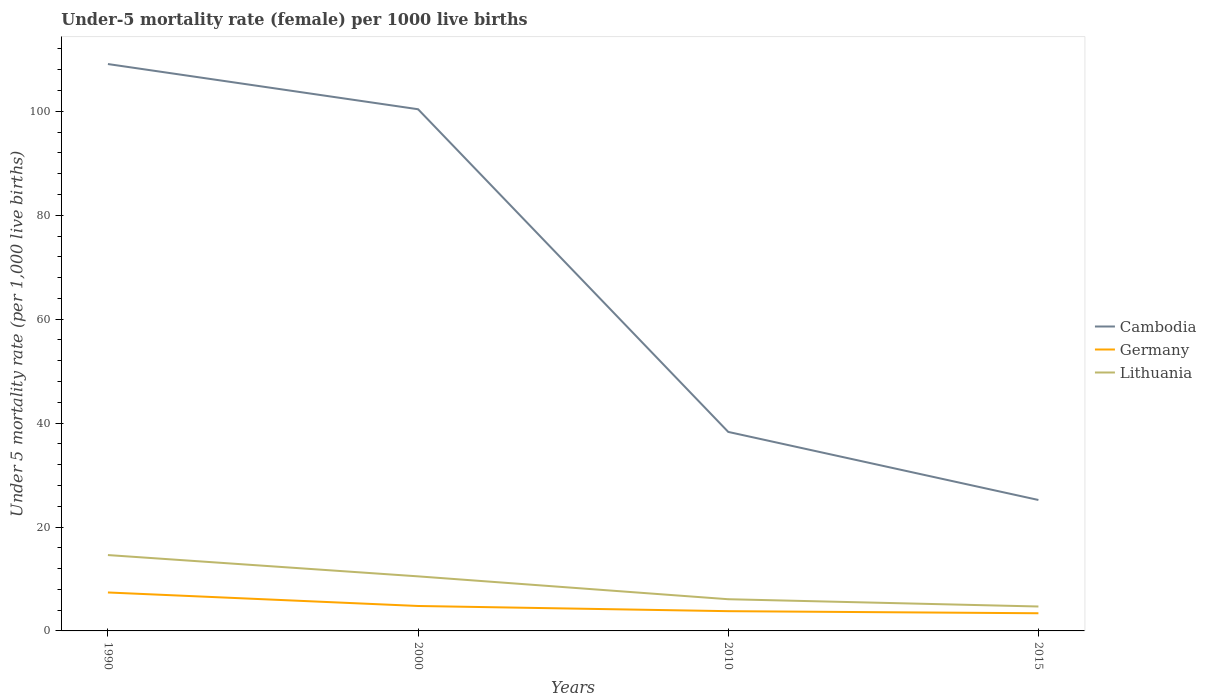Does the line corresponding to Lithuania intersect with the line corresponding to Cambodia?
Offer a very short reply. No. Across all years, what is the maximum under-five mortality rate in Cambodia?
Your response must be concise. 25.2. In which year was the under-five mortality rate in Lithuania maximum?
Provide a short and direct response. 2015. What is the difference between the highest and the second highest under-five mortality rate in Cambodia?
Give a very brief answer. 83.9. How many lines are there?
Provide a succinct answer. 3. Does the graph contain any zero values?
Ensure brevity in your answer.  No. How many legend labels are there?
Your response must be concise. 3. How are the legend labels stacked?
Your answer should be very brief. Vertical. What is the title of the graph?
Your response must be concise. Under-5 mortality rate (female) per 1000 live births. What is the label or title of the X-axis?
Your answer should be compact. Years. What is the label or title of the Y-axis?
Give a very brief answer. Under 5 mortality rate (per 1,0 live births). What is the Under 5 mortality rate (per 1,000 live births) in Cambodia in 1990?
Make the answer very short. 109.1. What is the Under 5 mortality rate (per 1,000 live births) in Lithuania in 1990?
Ensure brevity in your answer.  14.6. What is the Under 5 mortality rate (per 1,000 live births) of Cambodia in 2000?
Give a very brief answer. 100.4. What is the Under 5 mortality rate (per 1,000 live births) in Germany in 2000?
Your answer should be very brief. 4.8. What is the Under 5 mortality rate (per 1,000 live births) of Cambodia in 2010?
Provide a succinct answer. 38.3. What is the Under 5 mortality rate (per 1,000 live births) of Cambodia in 2015?
Your answer should be very brief. 25.2. What is the Under 5 mortality rate (per 1,000 live births) in Germany in 2015?
Offer a very short reply. 3.4. Across all years, what is the maximum Under 5 mortality rate (per 1,000 live births) of Cambodia?
Your answer should be very brief. 109.1. Across all years, what is the maximum Under 5 mortality rate (per 1,000 live births) in Lithuania?
Ensure brevity in your answer.  14.6. Across all years, what is the minimum Under 5 mortality rate (per 1,000 live births) of Cambodia?
Offer a terse response. 25.2. Across all years, what is the minimum Under 5 mortality rate (per 1,000 live births) in Germany?
Offer a very short reply. 3.4. Across all years, what is the minimum Under 5 mortality rate (per 1,000 live births) of Lithuania?
Offer a very short reply. 4.7. What is the total Under 5 mortality rate (per 1,000 live births) of Cambodia in the graph?
Your answer should be compact. 273. What is the total Under 5 mortality rate (per 1,000 live births) of Germany in the graph?
Ensure brevity in your answer.  19.4. What is the total Under 5 mortality rate (per 1,000 live births) in Lithuania in the graph?
Give a very brief answer. 35.9. What is the difference between the Under 5 mortality rate (per 1,000 live births) of Cambodia in 1990 and that in 2000?
Your answer should be very brief. 8.7. What is the difference between the Under 5 mortality rate (per 1,000 live births) in Lithuania in 1990 and that in 2000?
Provide a short and direct response. 4.1. What is the difference between the Under 5 mortality rate (per 1,000 live births) in Cambodia in 1990 and that in 2010?
Give a very brief answer. 70.8. What is the difference between the Under 5 mortality rate (per 1,000 live births) in Germany in 1990 and that in 2010?
Give a very brief answer. 3.6. What is the difference between the Under 5 mortality rate (per 1,000 live births) in Lithuania in 1990 and that in 2010?
Ensure brevity in your answer.  8.5. What is the difference between the Under 5 mortality rate (per 1,000 live births) in Cambodia in 1990 and that in 2015?
Provide a succinct answer. 83.9. What is the difference between the Under 5 mortality rate (per 1,000 live births) in Cambodia in 2000 and that in 2010?
Provide a short and direct response. 62.1. What is the difference between the Under 5 mortality rate (per 1,000 live births) of Lithuania in 2000 and that in 2010?
Your response must be concise. 4.4. What is the difference between the Under 5 mortality rate (per 1,000 live births) of Cambodia in 2000 and that in 2015?
Offer a terse response. 75.2. What is the difference between the Under 5 mortality rate (per 1,000 live births) in Germany in 2000 and that in 2015?
Your answer should be very brief. 1.4. What is the difference between the Under 5 mortality rate (per 1,000 live births) of Lithuania in 2000 and that in 2015?
Provide a succinct answer. 5.8. What is the difference between the Under 5 mortality rate (per 1,000 live births) in Lithuania in 2010 and that in 2015?
Keep it short and to the point. 1.4. What is the difference between the Under 5 mortality rate (per 1,000 live births) of Cambodia in 1990 and the Under 5 mortality rate (per 1,000 live births) of Germany in 2000?
Provide a succinct answer. 104.3. What is the difference between the Under 5 mortality rate (per 1,000 live births) in Cambodia in 1990 and the Under 5 mortality rate (per 1,000 live births) in Lithuania in 2000?
Your answer should be very brief. 98.6. What is the difference between the Under 5 mortality rate (per 1,000 live births) in Germany in 1990 and the Under 5 mortality rate (per 1,000 live births) in Lithuania in 2000?
Provide a succinct answer. -3.1. What is the difference between the Under 5 mortality rate (per 1,000 live births) in Cambodia in 1990 and the Under 5 mortality rate (per 1,000 live births) in Germany in 2010?
Ensure brevity in your answer.  105.3. What is the difference between the Under 5 mortality rate (per 1,000 live births) in Cambodia in 1990 and the Under 5 mortality rate (per 1,000 live births) in Lithuania in 2010?
Keep it short and to the point. 103. What is the difference between the Under 5 mortality rate (per 1,000 live births) of Cambodia in 1990 and the Under 5 mortality rate (per 1,000 live births) of Germany in 2015?
Your answer should be very brief. 105.7. What is the difference between the Under 5 mortality rate (per 1,000 live births) in Cambodia in 1990 and the Under 5 mortality rate (per 1,000 live births) in Lithuania in 2015?
Offer a terse response. 104.4. What is the difference between the Under 5 mortality rate (per 1,000 live births) in Germany in 1990 and the Under 5 mortality rate (per 1,000 live births) in Lithuania in 2015?
Make the answer very short. 2.7. What is the difference between the Under 5 mortality rate (per 1,000 live births) in Cambodia in 2000 and the Under 5 mortality rate (per 1,000 live births) in Germany in 2010?
Offer a very short reply. 96.6. What is the difference between the Under 5 mortality rate (per 1,000 live births) in Cambodia in 2000 and the Under 5 mortality rate (per 1,000 live births) in Lithuania in 2010?
Keep it short and to the point. 94.3. What is the difference between the Under 5 mortality rate (per 1,000 live births) of Cambodia in 2000 and the Under 5 mortality rate (per 1,000 live births) of Germany in 2015?
Provide a succinct answer. 97. What is the difference between the Under 5 mortality rate (per 1,000 live births) of Cambodia in 2000 and the Under 5 mortality rate (per 1,000 live births) of Lithuania in 2015?
Keep it short and to the point. 95.7. What is the difference between the Under 5 mortality rate (per 1,000 live births) in Cambodia in 2010 and the Under 5 mortality rate (per 1,000 live births) in Germany in 2015?
Keep it short and to the point. 34.9. What is the difference between the Under 5 mortality rate (per 1,000 live births) in Cambodia in 2010 and the Under 5 mortality rate (per 1,000 live births) in Lithuania in 2015?
Your answer should be very brief. 33.6. What is the average Under 5 mortality rate (per 1,000 live births) in Cambodia per year?
Your answer should be compact. 68.25. What is the average Under 5 mortality rate (per 1,000 live births) of Germany per year?
Make the answer very short. 4.85. What is the average Under 5 mortality rate (per 1,000 live births) in Lithuania per year?
Your response must be concise. 8.97. In the year 1990, what is the difference between the Under 5 mortality rate (per 1,000 live births) in Cambodia and Under 5 mortality rate (per 1,000 live births) in Germany?
Offer a terse response. 101.7. In the year 1990, what is the difference between the Under 5 mortality rate (per 1,000 live births) of Cambodia and Under 5 mortality rate (per 1,000 live births) of Lithuania?
Your answer should be very brief. 94.5. In the year 1990, what is the difference between the Under 5 mortality rate (per 1,000 live births) in Germany and Under 5 mortality rate (per 1,000 live births) in Lithuania?
Your response must be concise. -7.2. In the year 2000, what is the difference between the Under 5 mortality rate (per 1,000 live births) of Cambodia and Under 5 mortality rate (per 1,000 live births) of Germany?
Provide a short and direct response. 95.6. In the year 2000, what is the difference between the Under 5 mortality rate (per 1,000 live births) in Cambodia and Under 5 mortality rate (per 1,000 live births) in Lithuania?
Make the answer very short. 89.9. In the year 2010, what is the difference between the Under 5 mortality rate (per 1,000 live births) of Cambodia and Under 5 mortality rate (per 1,000 live births) of Germany?
Offer a terse response. 34.5. In the year 2010, what is the difference between the Under 5 mortality rate (per 1,000 live births) in Cambodia and Under 5 mortality rate (per 1,000 live births) in Lithuania?
Give a very brief answer. 32.2. In the year 2010, what is the difference between the Under 5 mortality rate (per 1,000 live births) of Germany and Under 5 mortality rate (per 1,000 live births) of Lithuania?
Keep it short and to the point. -2.3. In the year 2015, what is the difference between the Under 5 mortality rate (per 1,000 live births) of Cambodia and Under 5 mortality rate (per 1,000 live births) of Germany?
Your response must be concise. 21.8. What is the ratio of the Under 5 mortality rate (per 1,000 live births) in Cambodia in 1990 to that in 2000?
Provide a short and direct response. 1.09. What is the ratio of the Under 5 mortality rate (per 1,000 live births) of Germany in 1990 to that in 2000?
Offer a terse response. 1.54. What is the ratio of the Under 5 mortality rate (per 1,000 live births) of Lithuania in 1990 to that in 2000?
Provide a short and direct response. 1.39. What is the ratio of the Under 5 mortality rate (per 1,000 live births) of Cambodia in 1990 to that in 2010?
Make the answer very short. 2.85. What is the ratio of the Under 5 mortality rate (per 1,000 live births) of Germany in 1990 to that in 2010?
Keep it short and to the point. 1.95. What is the ratio of the Under 5 mortality rate (per 1,000 live births) in Lithuania in 1990 to that in 2010?
Give a very brief answer. 2.39. What is the ratio of the Under 5 mortality rate (per 1,000 live births) in Cambodia in 1990 to that in 2015?
Keep it short and to the point. 4.33. What is the ratio of the Under 5 mortality rate (per 1,000 live births) of Germany in 1990 to that in 2015?
Your response must be concise. 2.18. What is the ratio of the Under 5 mortality rate (per 1,000 live births) of Lithuania in 1990 to that in 2015?
Your answer should be compact. 3.11. What is the ratio of the Under 5 mortality rate (per 1,000 live births) of Cambodia in 2000 to that in 2010?
Provide a succinct answer. 2.62. What is the ratio of the Under 5 mortality rate (per 1,000 live births) of Germany in 2000 to that in 2010?
Your response must be concise. 1.26. What is the ratio of the Under 5 mortality rate (per 1,000 live births) of Lithuania in 2000 to that in 2010?
Make the answer very short. 1.72. What is the ratio of the Under 5 mortality rate (per 1,000 live births) of Cambodia in 2000 to that in 2015?
Keep it short and to the point. 3.98. What is the ratio of the Under 5 mortality rate (per 1,000 live births) of Germany in 2000 to that in 2015?
Your answer should be very brief. 1.41. What is the ratio of the Under 5 mortality rate (per 1,000 live births) of Lithuania in 2000 to that in 2015?
Ensure brevity in your answer.  2.23. What is the ratio of the Under 5 mortality rate (per 1,000 live births) in Cambodia in 2010 to that in 2015?
Keep it short and to the point. 1.52. What is the ratio of the Under 5 mortality rate (per 1,000 live births) of Germany in 2010 to that in 2015?
Make the answer very short. 1.12. What is the ratio of the Under 5 mortality rate (per 1,000 live births) of Lithuania in 2010 to that in 2015?
Keep it short and to the point. 1.3. What is the difference between the highest and the second highest Under 5 mortality rate (per 1,000 live births) of Cambodia?
Your response must be concise. 8.7. What is the difference between the highest and the second highest Under 5 mortality rate (per 1,000 live births) of Germany?
Your response must be concise. 2.6. What is the difference between the highest and the second highest Under 5 mortality rate (per 1,000 live births) in Lithuania?
Make the answer very short. 4.1. What is the difference between the highest and the lowest Under 5 mortality rate (per 1,000 live births) of Cambodia?
Make the answer very short. 83.9. What is the difference between the highest and the lowest Under 5 mortality rate (per 1,000 live births) in Germany?
Provide a succinct answer. 4. What is the difference between the highest and the lowest Under 5 mortality rate (per 1,000 live births) in Lithuania?
Offer a terse response. 9.9. 